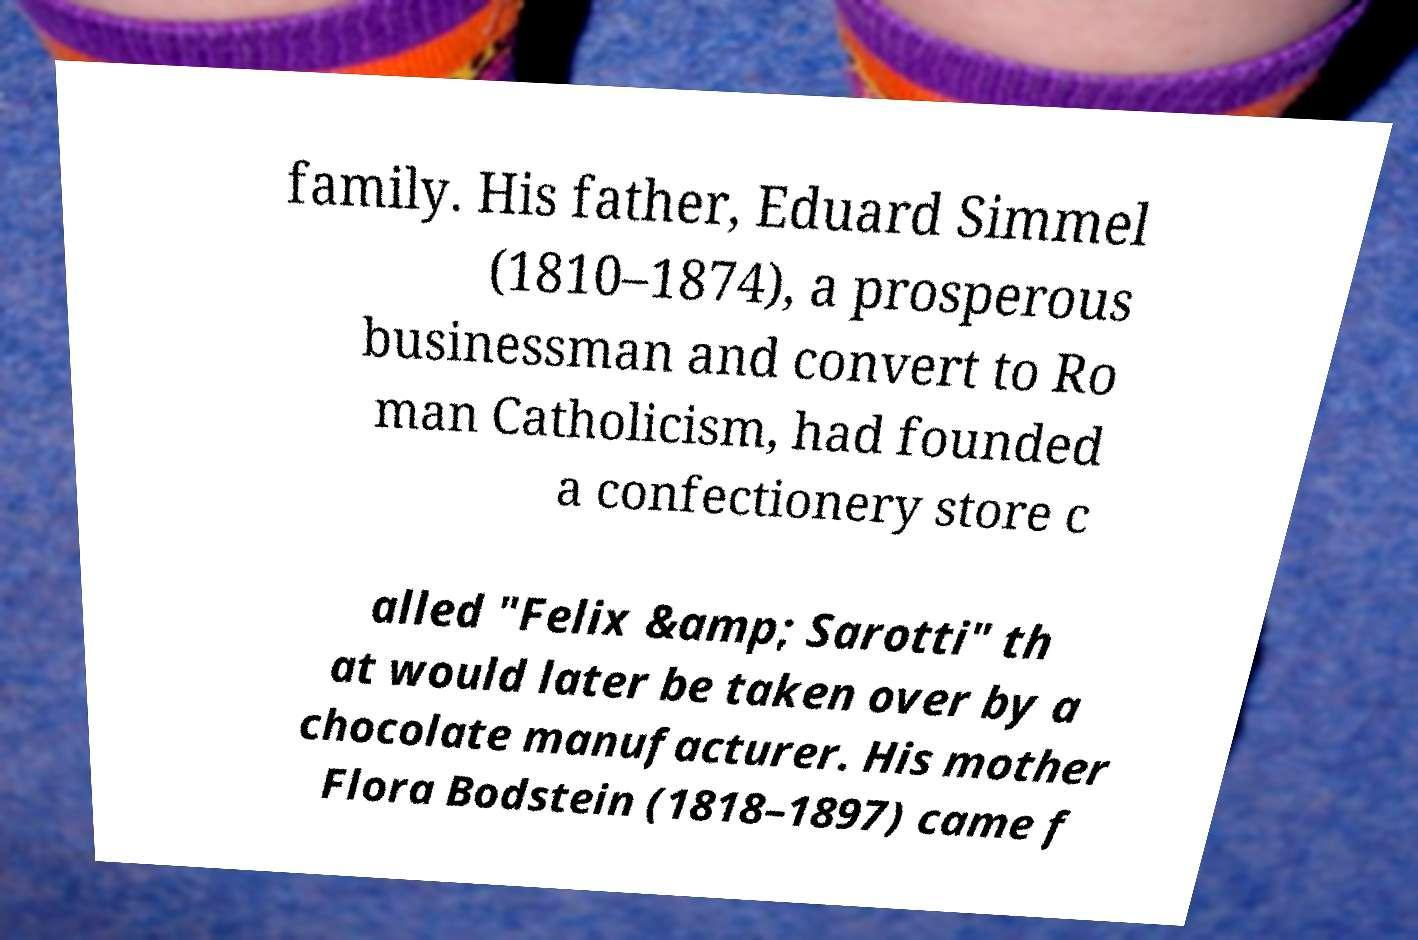I need the written content from this picture converted into text. Can you do that? family. His father, Eduard Simmel (1810–1874), a prosperous businessman and convert to Ro man Catholicism, had founded a confectionery store c alled "Felix &amp; Sarotti" th at would later be taken over by a chocolate manufacturer. His mother Flora Bodstein (1818–1897) came f 